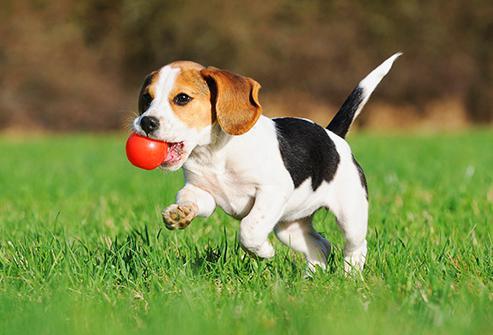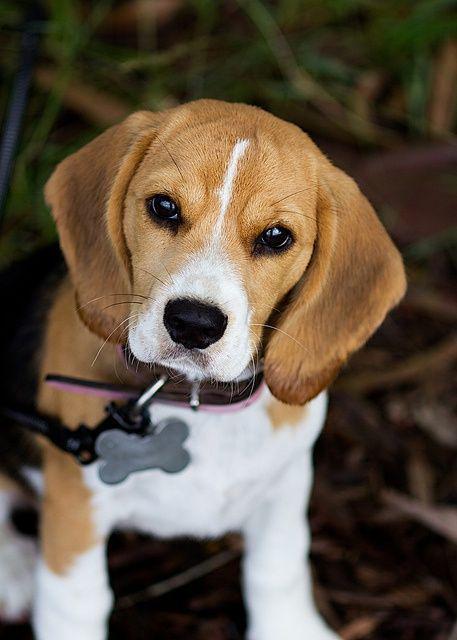The first image is the image on the left, the second image is the image on the right. Considering the images on both sides, is "In the right image, the beagle wears a leash." valid? Answer yes or no. Yes. The first image is the image on the left, the second image is the image on the right. For the images shown, is this caption "An image shows a sitting beagle eyeing the camera, with a tag dangling from its collar." true? Answer yes or no. Yes. 